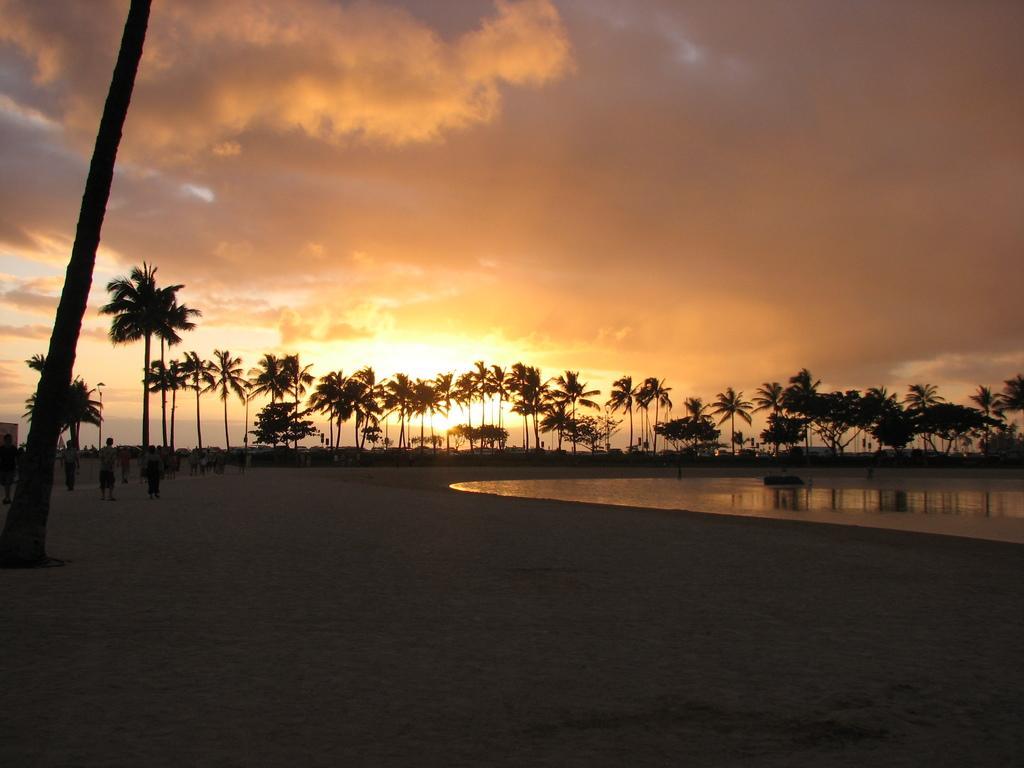Could you give a brief overview of what you see in this image? Here in this picture, on the left side we can see people standing and walking on the ground and on the right side we can see water present over the place and we can also see plants and trees covered over there and we can see sun and clouds in the sky. 